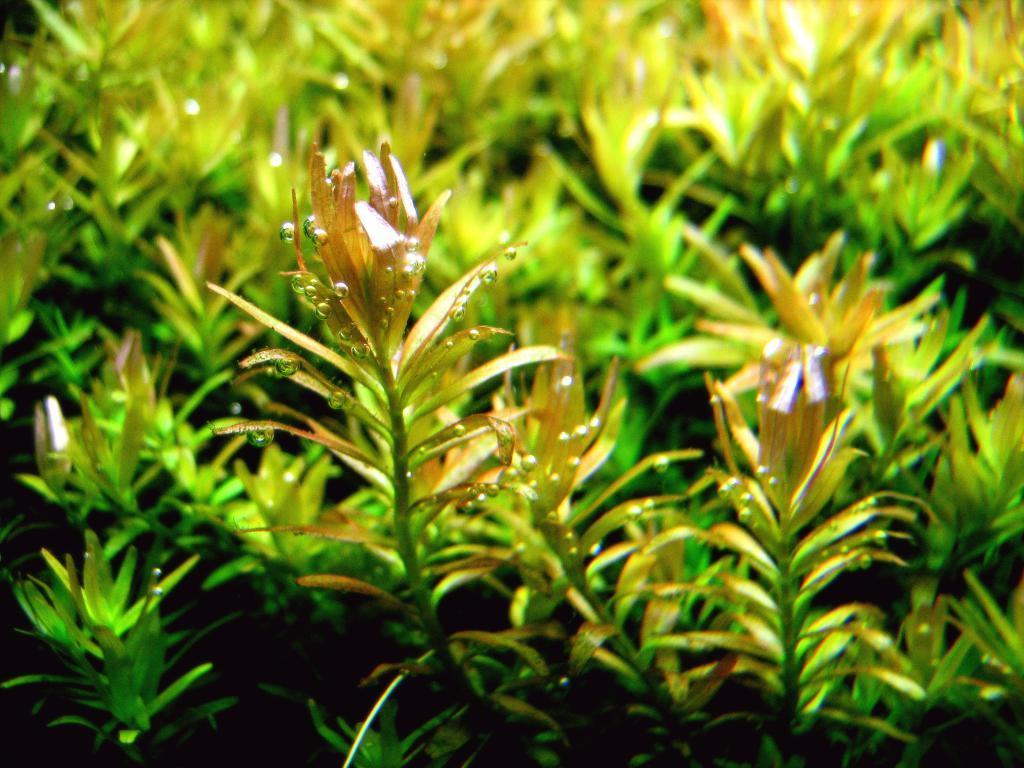What type of living organisms can be seen in the image? Plants can be seen in the image. What type of engine is powering the bushes in the image? There are no bushes or engines present in the image; it only features plants. What does the queen do in the image? There is no queen present in the image; it only features plants. 